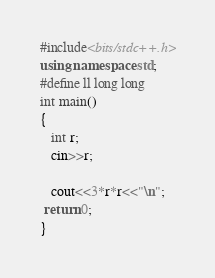<code> <loc_0><loc_0><loc_500><loc_500><_C++_>#include<bits/stdc++.h>
using namespace std;
#define ll long long
int main()
{
   int r;
   cin>>r;

   cout<<3*r*r<<"\n";
 return 0;
}
</code> 